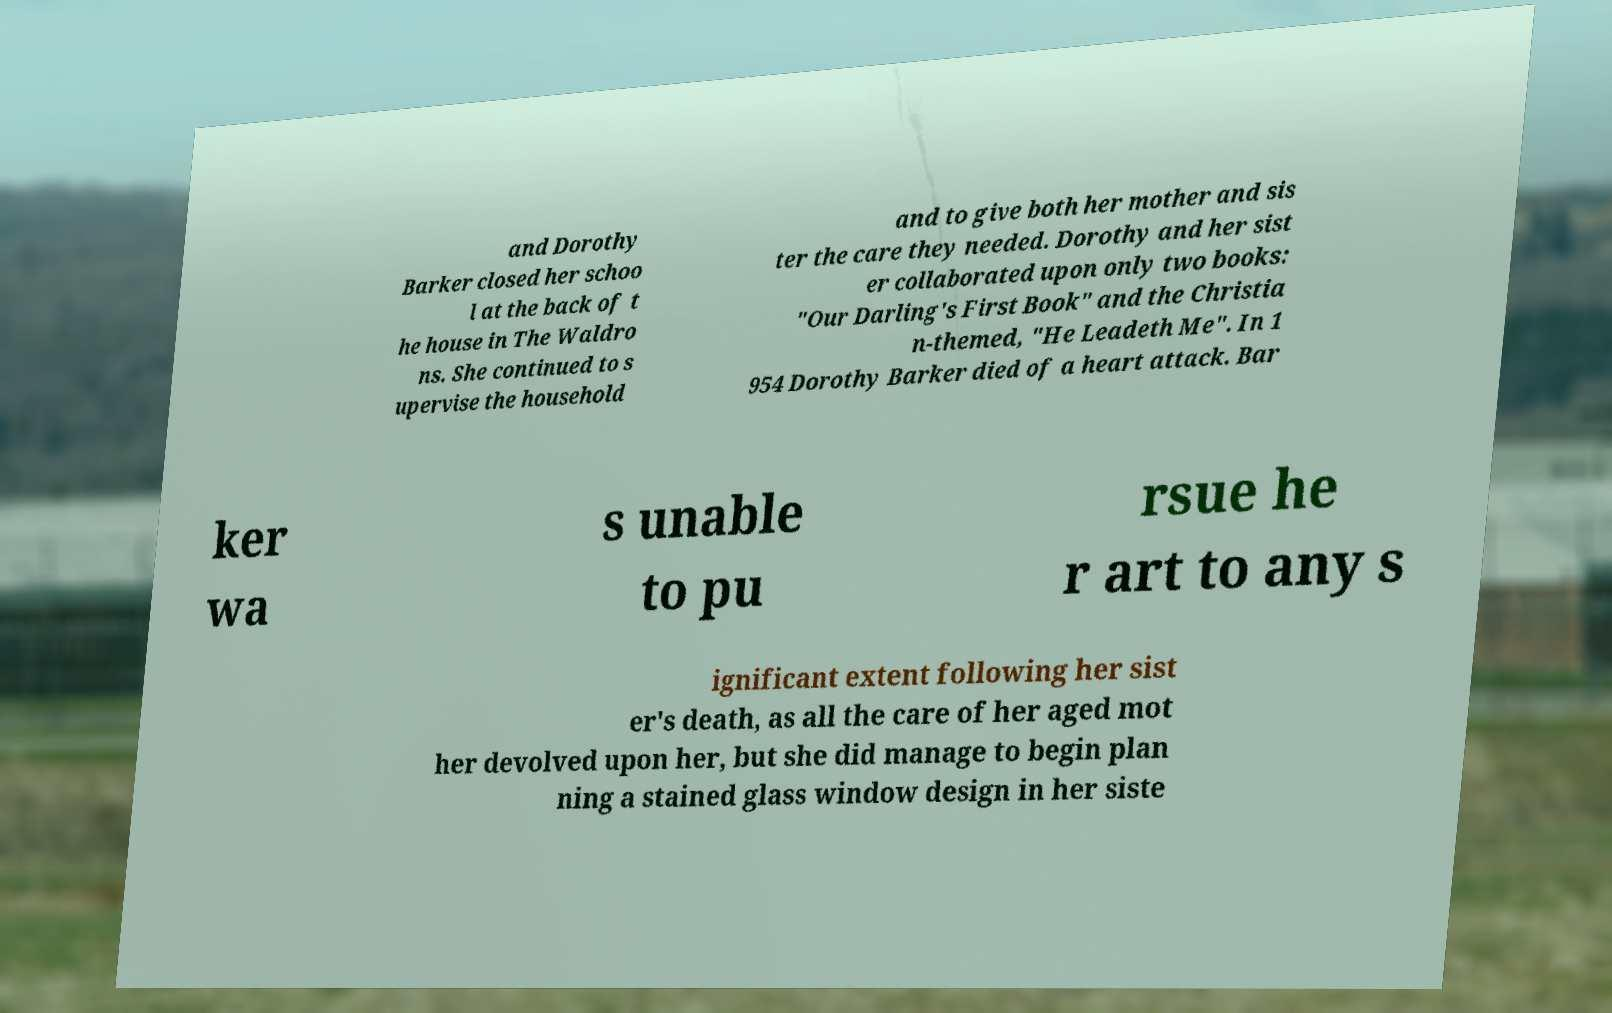Please read and relay the text visible in this image. What does it say? and Dorothy Barker closed her schoo l at the back of t he house in The Waldro ns. She continued to s upervise the household and to give both her mother and sis ter the care they needed. Dorothy and her sist er collaborated upon only two books: "Our Darling's First Book" and the Christia n-themed, "He Leadeth Me". In 1 954 Dorothy Barker died of a heart attack. Bar ker wa s unable to pu rsue he r art to any s ignificant extent following her sist er's death, as all the care of her aged mot her devolved upon her, but she did manage to begin plan ning a stained glass window design in her siste 